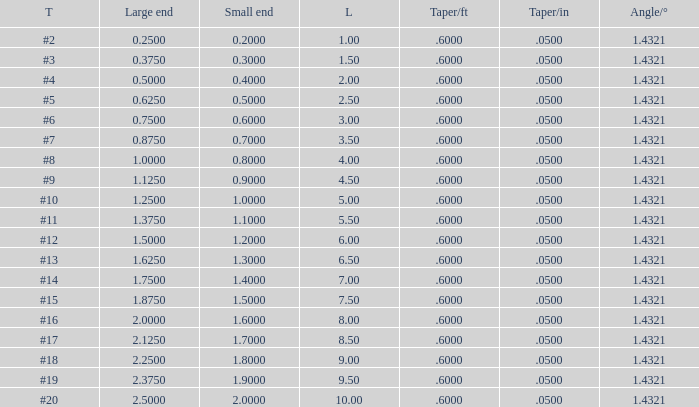Which Length has a Taper of #15, and a Large end larger than 1.875? None. 